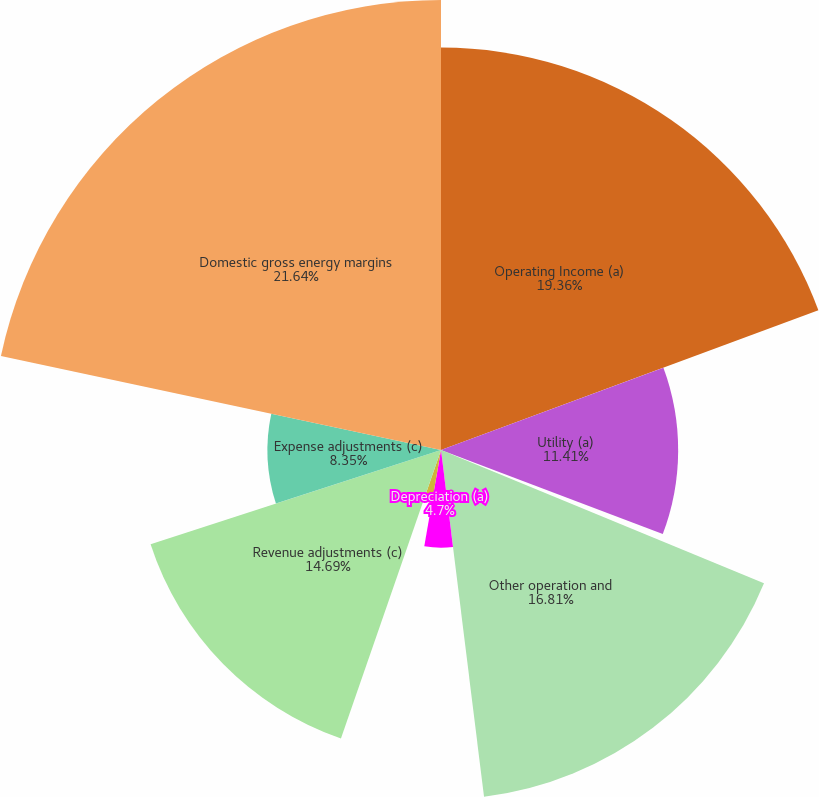Convert chart. <chart><loc_0><loc_0><loc_500><loc_500><pie_chart><fcel>Operating Income (a)<fcel>Utility (a)<fcel>Energy-related businesses net<fcel>Other operation and<fcel>Depreciation (a)<fcel>Taxes other than income (a)<fcel>Revenue adjustments (c)<fcel>Expense adjustments (c)<fcel>Domestic gross energy margins<nl><fcel>19.36%<fcel>11.41%<fcel>0.46%<fcel>16.81%<fcel>4.7%<fcel>2.58%<fcel>14.69%<fcel>8.35%<fcel>21.65%<nl></chart> 